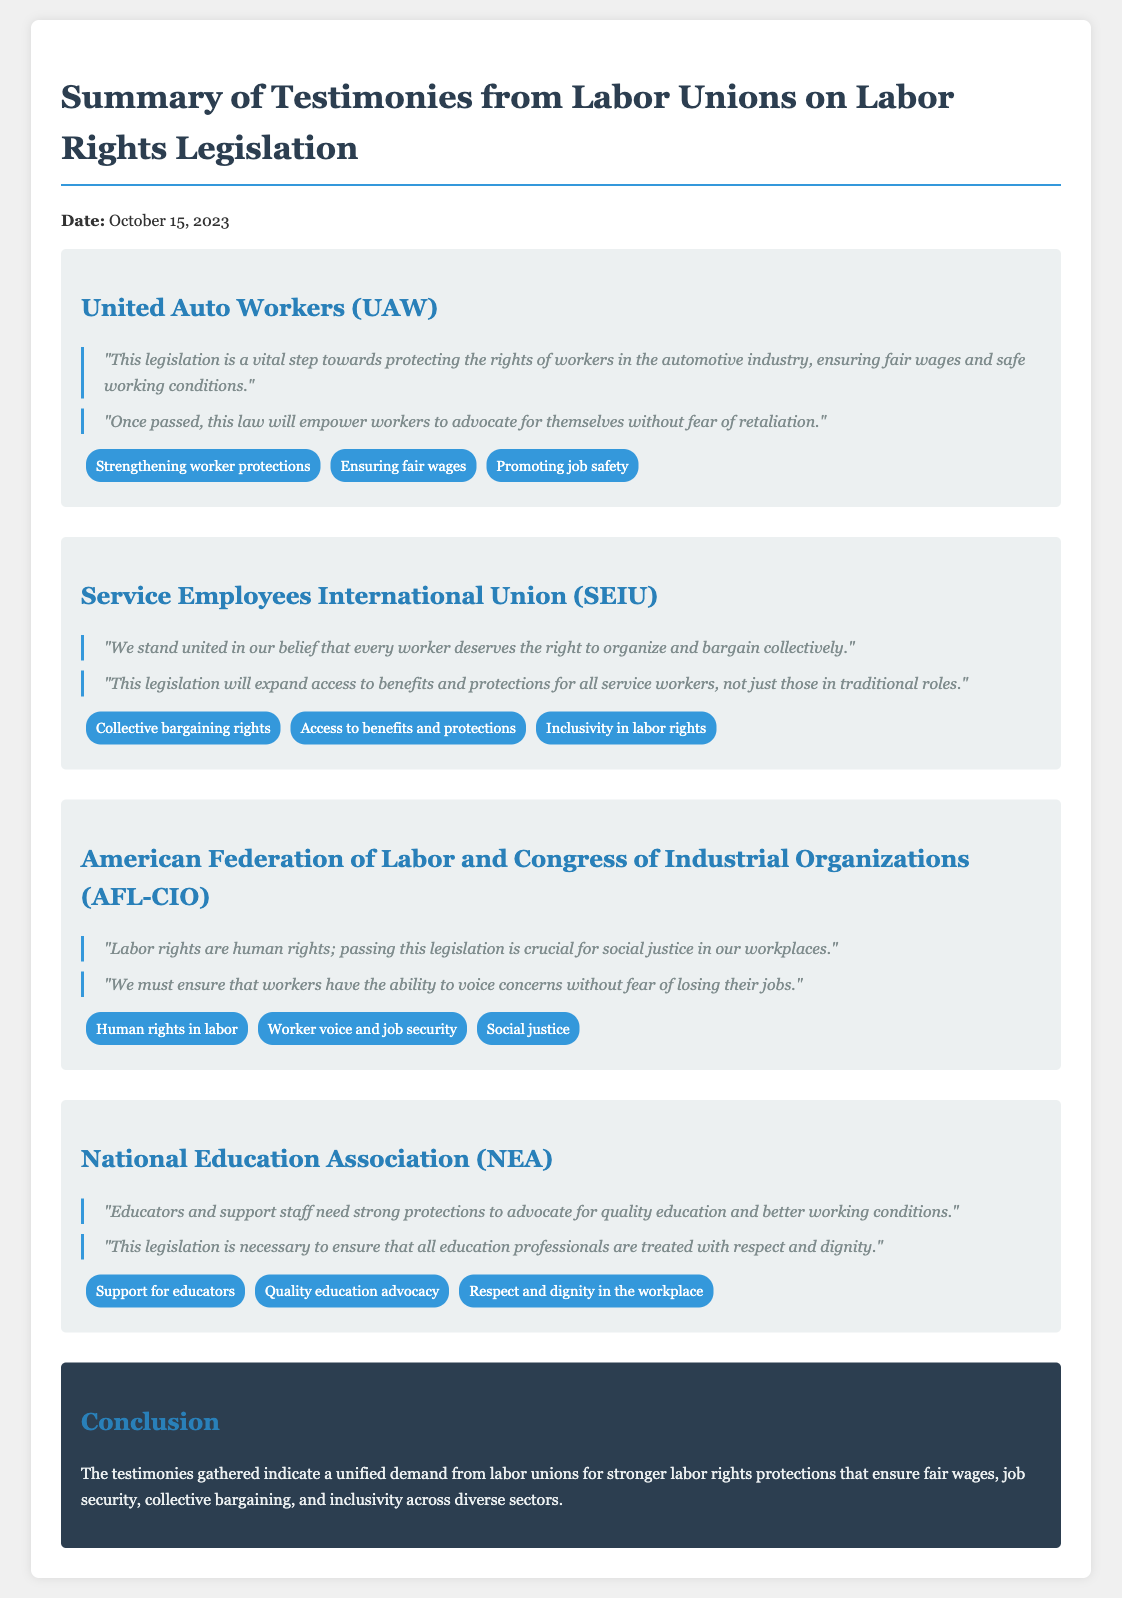What is the date of the testimonies? The date is stated at the beginning of the document.
Answer: October 15, 2023 Which union emphasized the importance of job safety? The United Auto Workers (UAW) mentioned job safety in their quotes.
Answer: United Auto Workers (UAW) What theme is associated with the Service Employees International Union (SEIU)? The themes listed for SEIU highlight their stance on collective bargaining rights.
Answer: Collective bargaining rights What phrase did the AFL-CIO use to describe labor rights? This phrase is included in their quotes, emphasizing the importance of labor rights.
Answer: Labor rights are human rights Which union supports educators and advocates for quality education? The National Education Association (NEA) specifically mentions support for educators.
Answer: National Education Association (NEA) How many unions provided testimonies in the document? The document lists four unions that provided testimonies.
Answer: Four unions What is the overall conclusion drawn from the testimonies? The conclusion summarizes the demands of labor unions regarding labor rights protections.
Answer: Stronger labor rights protections Which union quoted about the ability to voice concerns without fear? This quote was made by the AFL-CIO regarding job security.
Answer: American Federation of Labor and Congress of Industrial Organizations (AFL-CIO) 